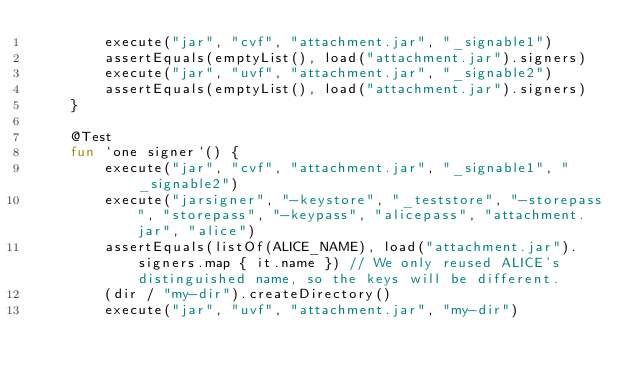<code> <loc_0><loc_0><loc_500><loc_500><_Kotlin_>        execute("jar", "cvf", "attachment.jar", "_signable1")
        assertEquals(emptyList(), load("attachment.jar").signers)
        execute("jar", "uvf", "attachment.jar", "_signable2")
        assertEquals(emptyList(), load("attachment.jar").signers)
    }

    @Test
    fun `one signer`() {
        execute("jar", "cvf", "attachment.jar", "_signable1", "_signable2")
        execute("jarsigner", "-keystore", "_teststore", "-storepass", "storepass", "-keypass", "alicepass", "attachment.jar", "alice")
        assertEquals(listOf(ALICE_NAME), load("attachment.jar").signers.map { it.name }) // We only reused ALICE's distinguished name, so the keys will be different.
        (dir / "my-dir").createDirectory()
        execute("jar", "uvf", "attachment.jar", "my-dir")</code> 